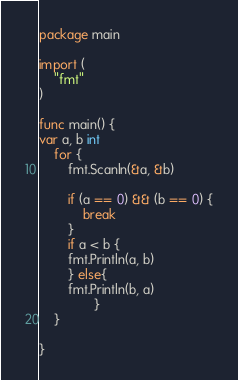<code> <loc_0><loc_0><loc_500><loc_500><_Go_>package main

import (
	"fmt"
)

func main() {
var a, b int
	for {
		fmt.Scanln(&a, &b)

		if (a == 0) && (b == 0) {
			break
		}
		if a < b {
		fmt.Println(a, b)
		} else{
		fmt.Println(b, a)
               }
	}

}


</code> 